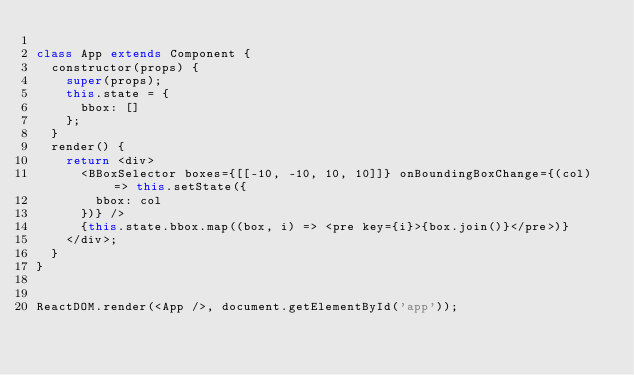Convert code to text. <code><loc_0><loc_0><loc_500><loc_500><_JavaScript_>
class App extends Component {
  constructor(props) {
    super(props);
    this.state = {
      bbox: []
    };
  }
  render() {
    return <div>
      <BBoxSelector boxes={[[-10, -10, 10, 10]]} onBoundingBoxChange={(col) => this.setState({
        bbox: col
      })} />
      {this.state.bbox.map((box, i) => <pre key={i}>{box.join()}</pre>)}
    </div>;
  }
}


ReactDOM.render(<App />, document.getElementById('app'));
</code> 